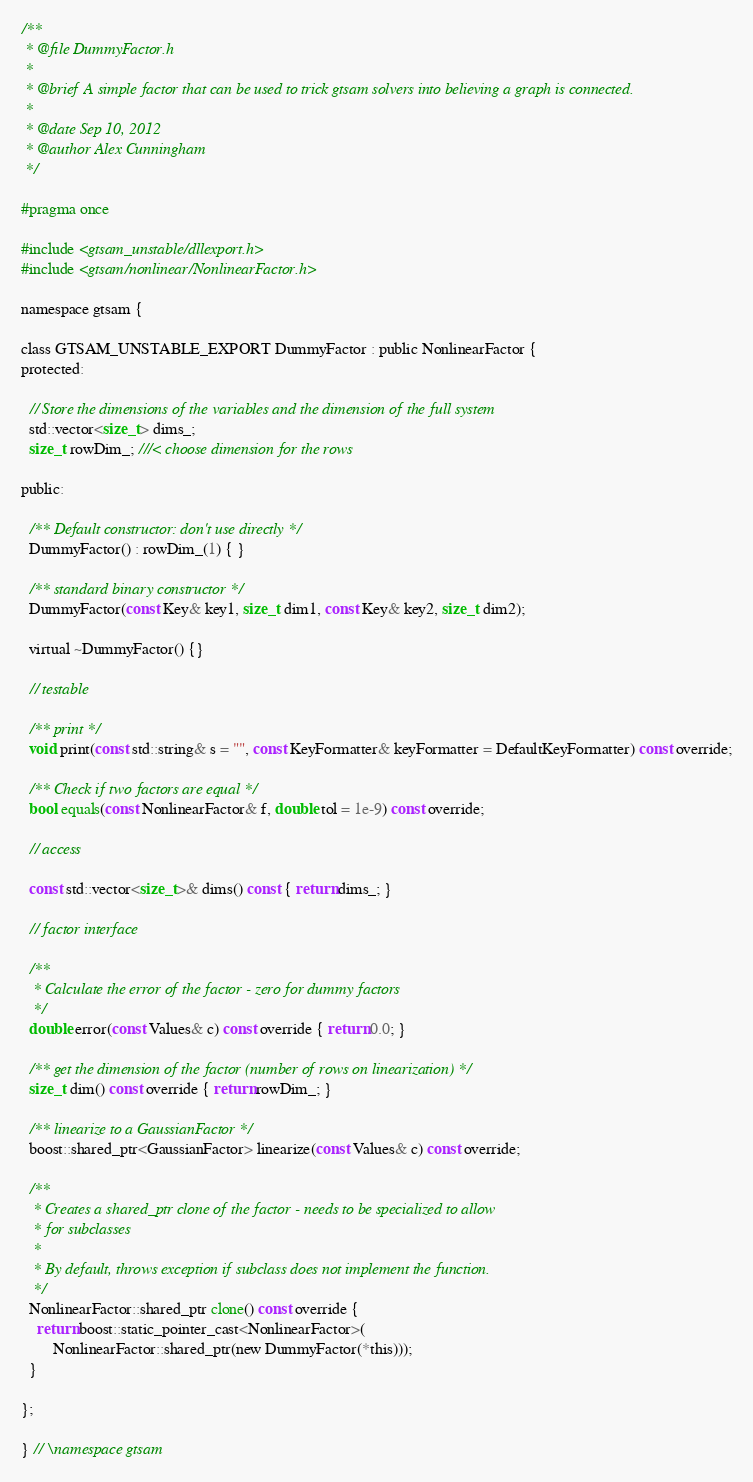Convert code to text. <code><loc_0><loc_0><loc_500><loc_500><_C_>/**
 * @file DummyFactor.h
 *
 * @brief A simple factor that can be used to trick gtsam solvers into believing a graph is connected.
 *
 * @date Sep 10, 2012
 * @author Alex Cunningham
 */

#pragma once

#include <gtsam_unstable/dllexport.h>
#include <gtsam/nonlinear/NonlinearFactor.h>

namespace gtsam {

class GTSAM_UNSTABLE_EXPORT DummyFactor : public NonlinearFactor {
protected:

  // Store the dimensions of the variables and the dimension of the full system
  std::vector<size_t> dims_;
  size_t rowDim_; ///< choose dimension for the rows

public:

  /** Default constructor: don't use directly */
  DummyFactor() : rowDim_(1) { }

  /** standard binary constructor */
  DummyFactor(const Key& key1, size_t dim1, const Key& key2, size_t dim2);

  virtual ~DummyFactor() {}

  // testable

  /** print */
  void print(const std::string& s = "", const KeyFormatter& keyFormatter = DefaultKeyFormatter) const override;

  /** Check if two factors are equal */
  bool equals(const NonlinearFactor& f, double tol = 1e-9) const override;

  // access

  const std::vector<size_t>& dims() const { return dims_; }

  // factor interface

  /**
   * Calculate the error of the factor - zero for dummy factors
   */
  double error(const Values& c) const override { return 0.0; }

  /** get the dimension of the factor (number of rows on linearization) */
  size_t dim() const override { return rowDim_; }

  /** linearize to a GaussianFactor */
  boost::shared_ptr<GaussianFactor> linearize(const Values& c) const override;

  /**
   * Creates a shared_ptr clone of the factor - needs to be specialized to allow
   * for subclasses
   *
   * By default, throws exception if subclass does not implement the function.
   */
  NonlinearFactor::shared_ptr clone() const override {
    return boost::static_pointer_cast<NonlinearFactor>(
        NonlinearFactor::shared_ptr(new DummyFactor(*this)));
  }

};

} // \namespace gtsam




</code> 